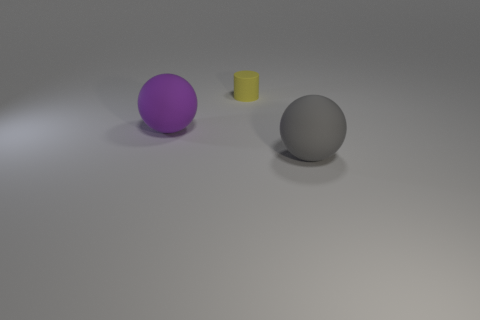Add 2 yellow cylinders. How many objects exist? 5 Subtract 0 cyan cylinders. How many objects are left? 3 Subtract all cylinders. How many objects are left? 2 Subtract all cyan balls. Subtract all red cylinders. How many balls are left? 2 Subtract all cyan cylinders. How many gray balls are left? 1 Subtract all blue matte cylinders. Subtract all large things. How many objects are left? 1 Add 2 yellow things. How many yellow things are left? 3 Add 2 large gray metal blocks. How many large gray metal blocks exist? 2 